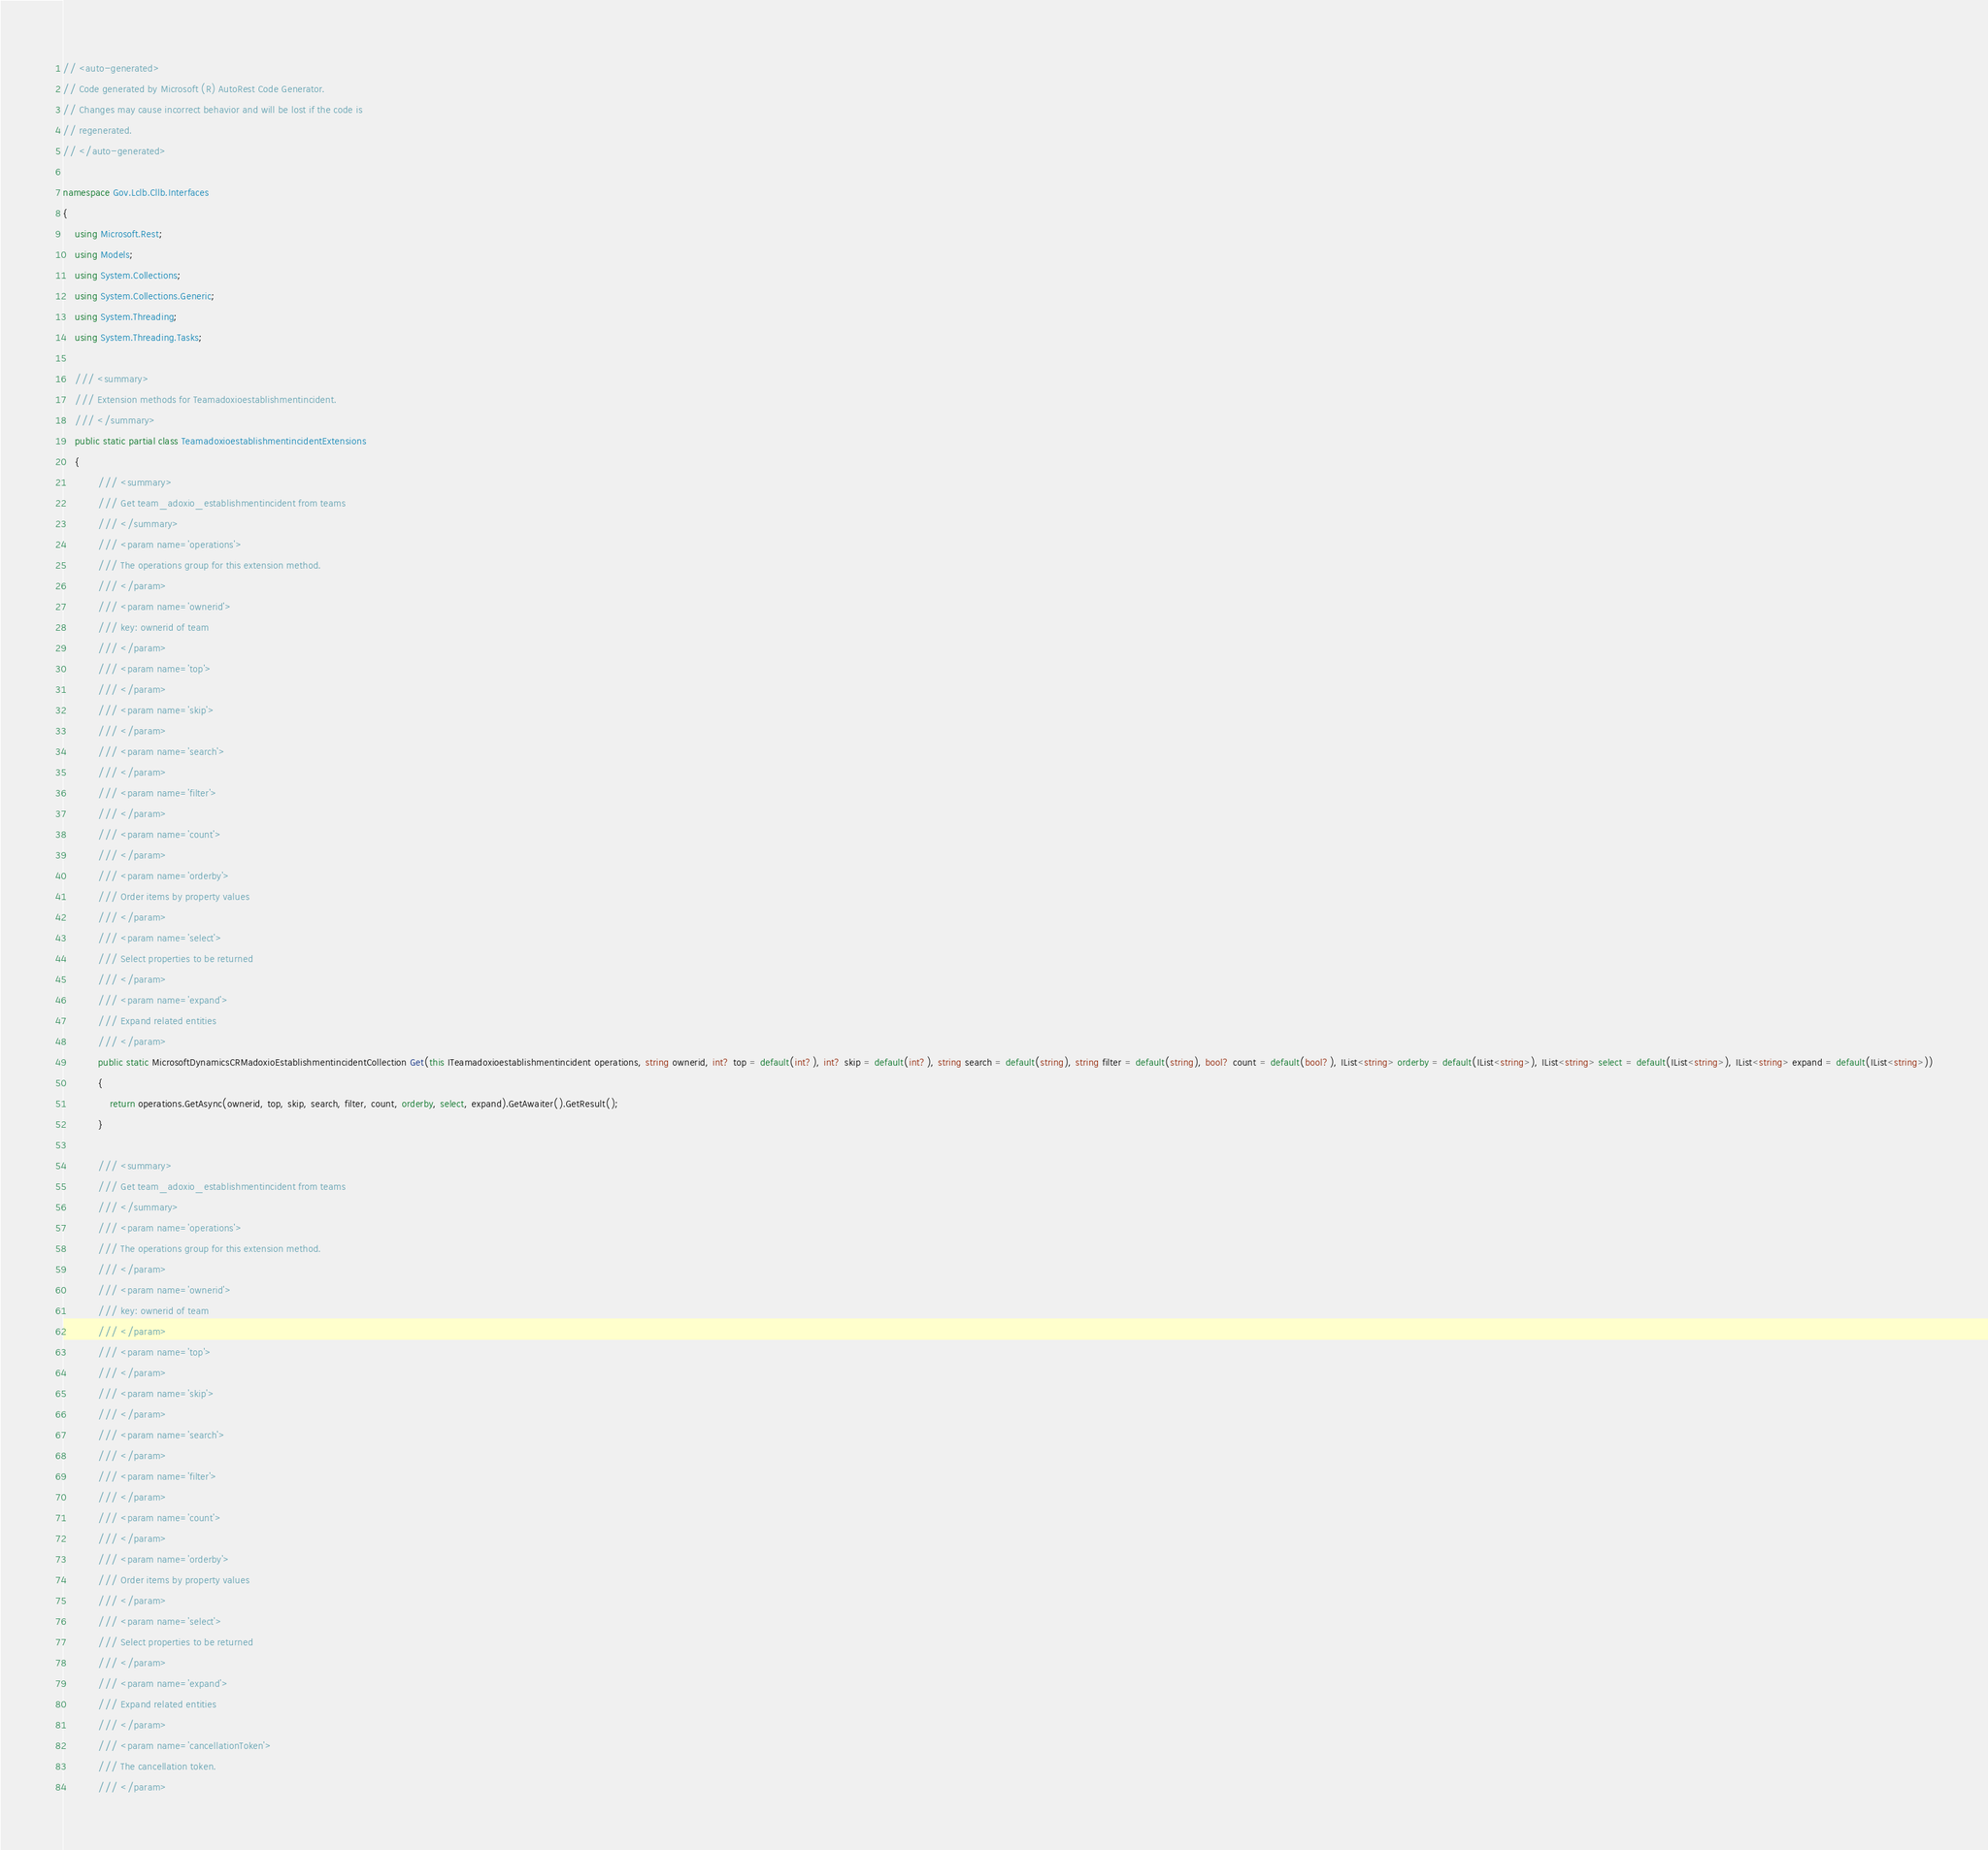<code> <loc_0><loc_0><loc_500><loc_500><_C#_>// <auto-generated>
// Code generated by Microsoft (R) AutoRest Code Generator.
// Changes may cause incorrect behavior and will be lost if the code is
// regenerated.
// </auto-generated>

namespace Gov.Lclb.Cllb.Interfaces
{
    using Microsoft.Rest;
    using Models;
    using System.Collections;
    using System.Collections.Generic;
    using System.Threading;
    using System.Threading.Tasks;

    /// <summary>
    /// Extension methods for Teamadoxioestablishmentincident.
    /// </summary>
    public static partial class TeamadoxioestablishmentincidentExtensions
    {
            /// <summary>
            /// Get team_adoxio_establishmentincident from teams
            /// </summary>
            /// <param name='operations'>
            /// The operations group for this extension method.
            /// </param>
            /// <param name='ownerid'>
            /// key: ownerid of team
            /// </param>
            /// <param name='top'>
            /// </param>
            /// <param name='skip'>
            /// </param>
            /// <param name='search'>
            /// </param>
            /// <param name='filter'>
            /// </param>
            /// <param name='count'>
            /// </param>
            /// <param name='orderby'>
            /// Order items by property values
            /// </param>
            /// <param name='select'>
            /// Select properties to be returned
            /// </param>
            /// <param name='expand'>
            /// Expand related entities
            /// </param>
            public static MicrosoftDynamicsCRMadoxioEstablishmentincidentCollection Get(this ITeamadoxioestablishmentincident operations, string ownerid, int? top = default(int?), int? skip = default(int?), string search = default(string), string filter = default(string), bool? count = default(bool?), IList<string> orderby = default(IList<string>), IList<string> select = default(IList<string>), IList<string> expand = default(IList<string>))
            {
                return operations.GetAsync(ownerid, top, skip, search, filter, count, orderby, select, expand).GetAwaiter().GetResult();
            }

            /// <summary>
            /// Get team_adoxio_establishmentincident from teams
            /// </summary>
            /// <param name='operations'>
            /// The operations group for this extension method.
            /// </param>
            /// <param name='ownerid'>
            /// key: ownerid of team
            /// </param>
            /// <param name='top'>
            /// </param>
            /// <param name='skip'>
            /// </param>
            /// <param name='search'>
            /// </param>
            /// <param name='filter'>
            /// </param>
            /// <param name='count'>
            /// </param>
            /// <param name='orderby'>
            /// Order items by property values
            /// </param>
            /// <param name='select'>
            /// Select properties to be returned
            /// </param>
            /// <param name='expand'>
            /// Expand related entities
            /// </param>
            /// <param name='cancellationToken'>
            /// The cancellation token.
            /// </param></code> 